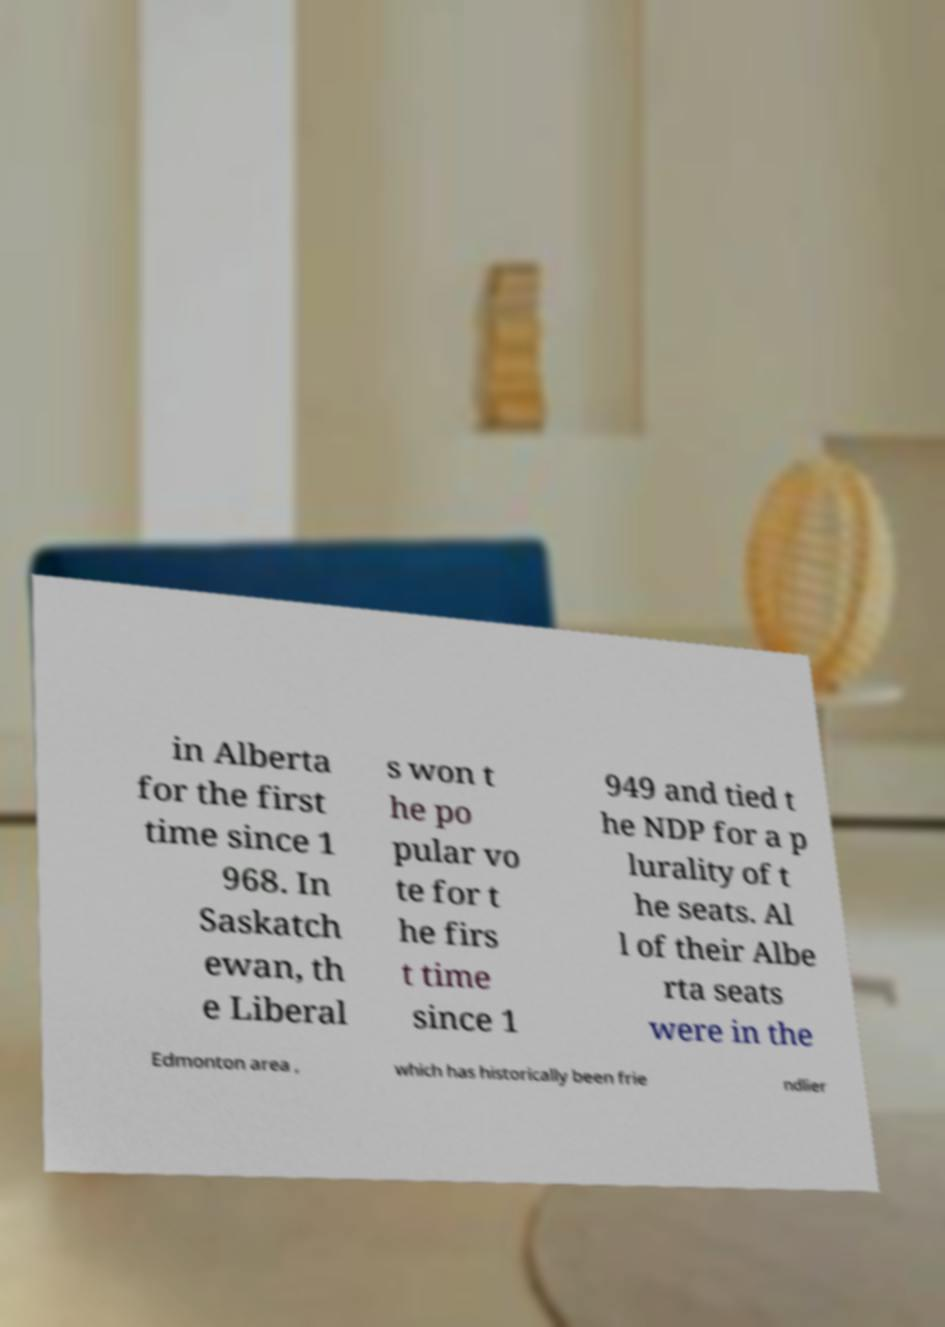Please read and relay the text visible in this image. What does it say? in Alberta for the first time since 1 968. In Saskatch ewan, th e Liberal s won t he po pular vo te for t he firs t time since 1 949 and tied t he NDP for a p lurality of t he seats. Al l of their Albe rta seats were in the Edmonton area , which has historically been frie ndlier 